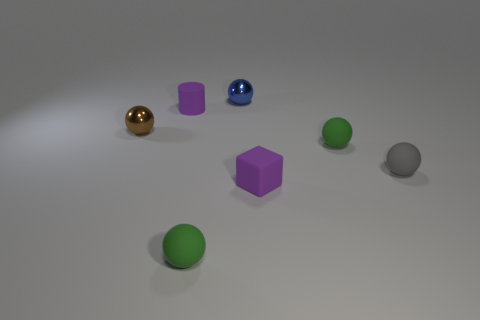Subtract all brown spheres. How many spheres are left? 4 Subtract 2 balls. How many balls are left? 3 Subtract all tiny brown metallic balls. How many balls are left? 4 Subtract all red balls. Subtract all purple cylinders. How many balls are left? 5 Add 2 green rubber things. How many objects exist? 9 Subtract all balls. How many objects are left? 2 Add 1 green spheres. How many green spheres are left? 3 Add 2 tiny brown things. How many tiny brown things exist? 3 Subtract 0 red cylinders. How many objects are left? 7 Subtract all tiny purple cylinders. Subtract all brown balls. How many objects are left? 5 